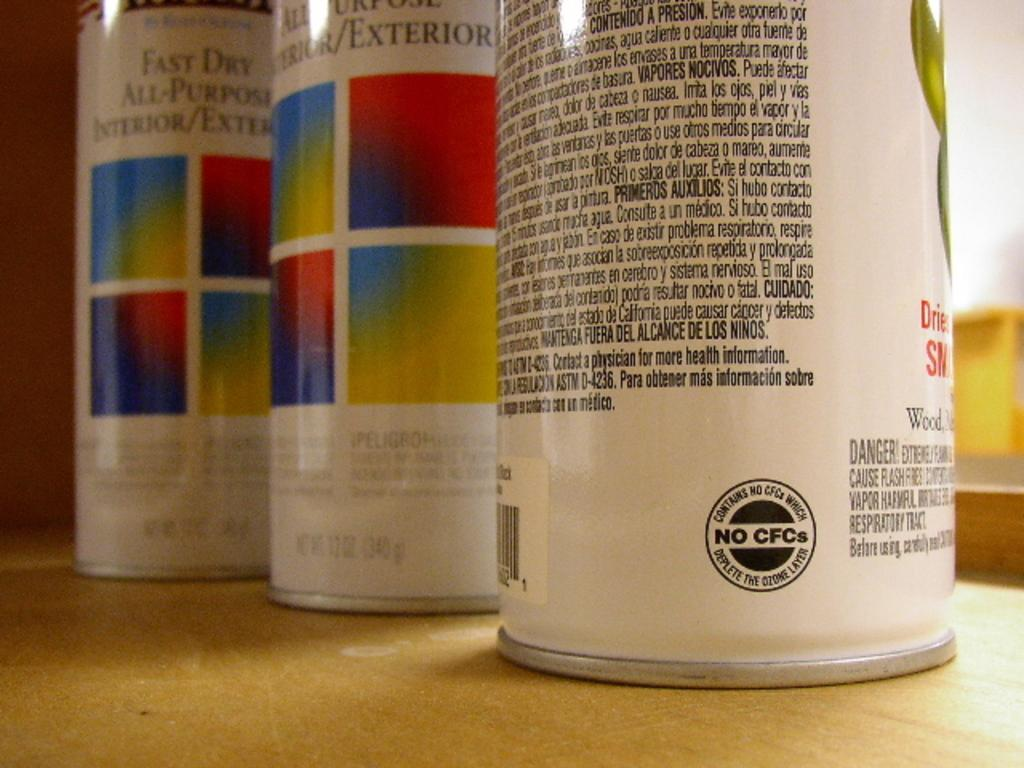<image>
Give a short and clear explanation of the subsequent image. 3 cans of Fast Dry All-Purpose Interior/Exterior paint are lined up on a surface. 